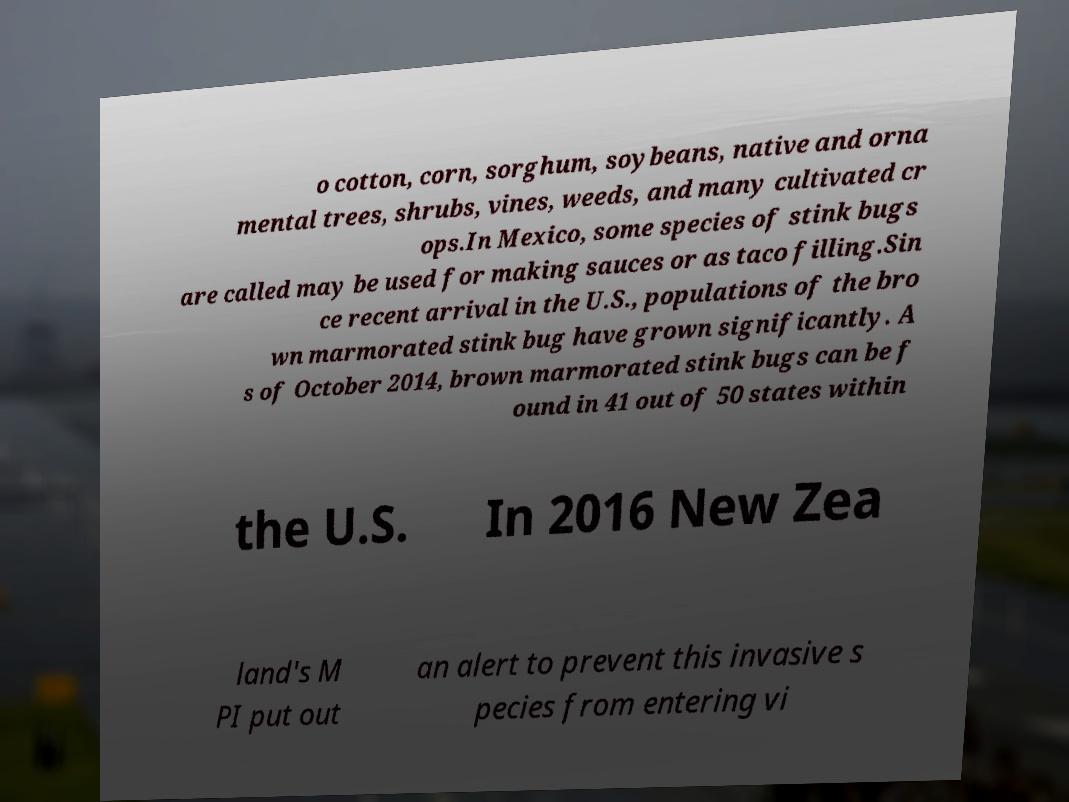Can you accurately transcribe the text from the provided image for me? o cotton, corn, sorghum, soybeans, native and orna mental trees, shrubs, vines, weeds, and many cultivated cr ops.In Mexico, some species of stink bugs are called may be used for making sauces or as taco filling.Sin ce recent arrival in the U.S., populations of the bro wn marmorated stink bug have grown significantly. A s of October 2014, brown marmorated stink bugs can be f ound in 41 out of 50 states within the U.S. In 2016 New Zea land's M PI put out an alert to prevent this invasive s pecies from entering vi 